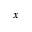Convert formula to latex. <formula><loc_0><loc_0><loc_500><loc_500>x</formula> 